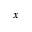Convert formula to latex. <formula><loc_0><loc_0><loc_500><loc_500>x</formula> 